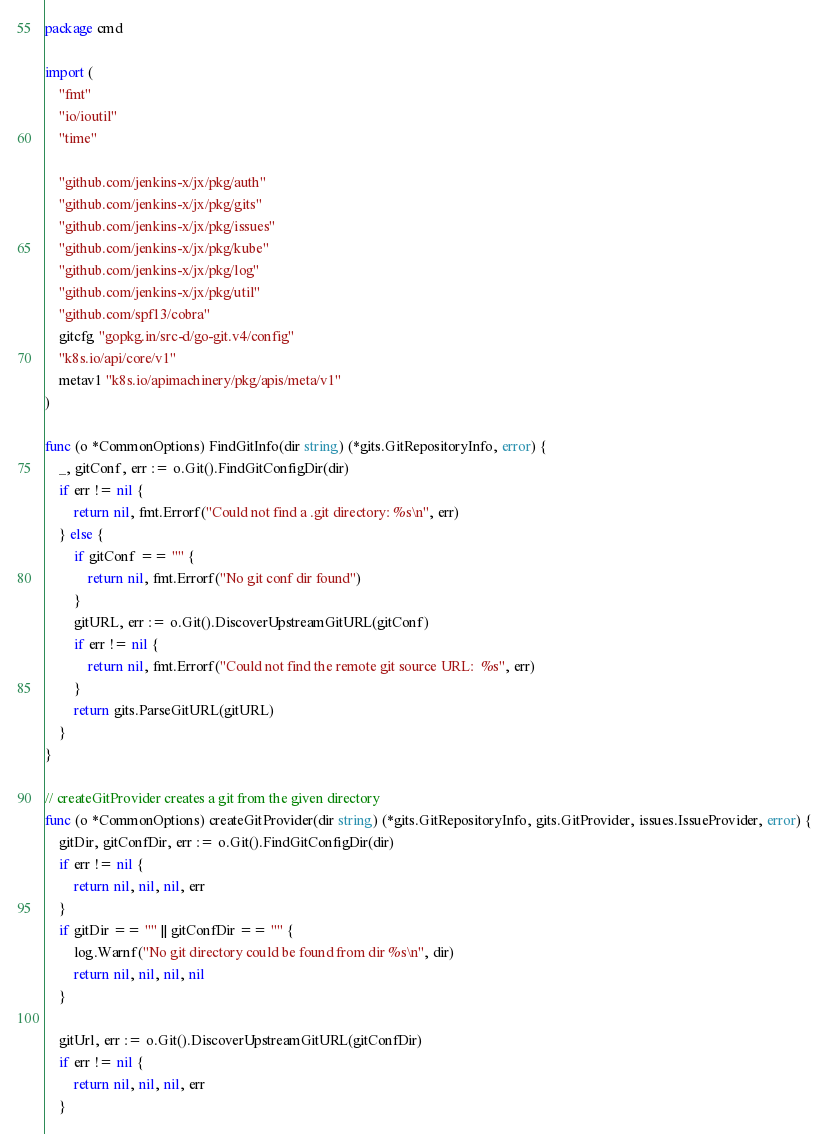<code> <loc_0><loc_0><loc_500><loc_500><_Go_>package cmd

import (
	"fmt"
	"io/ioutil"
	"time"

	"github.com/jenkins-x/jx/pkg/auth"
	"github.com/jenkins-x/jx/pkg/gits"
	"github.com/jenkins-x/jx/pkg/issues"
	"github.com/jenkins-x/jx/pkg/kube"
	"github.com/jenkins-x/jx/pkg/log"
	"github.com/jenkins-x/jx/pkg/util"
	"github.com/spf13/cobra"
	gitcfg "gopkg.in/src-d/go-git.v4/config"
	"k8s.io/api/core/v1"
	metav1 "k8s.io/apimachinery/pkg/apis/meta/v1"
)

func (o *CommonOptions) FindGitInfo(dir string) (*gits.GitRepositoryInfo, error) {
	_, gitConf, err := o.Git().FindGitConfigDir(dir)
	if err != nil {
		return nil, fmt.Errorf("Could not find a .git directory: %s\n", err)
	} else {
		if gitConf == "" {
			return nil, fmt.Errorf("No git conf dir found")
		}
		gitURL, err := o.Git().DiscoverUpstreamGitURL(gitConf)
		if err != nil {
			return nil, fmt.Errorf("Could not find the remote git source URL:  %s", err)
		}
		return gits.ParseGitURL(gitURL)
	}
}

// createGitProvider creates a git from the given directory
func (o *CommonOptions) createGitProvider(dir string) (*gits.GitRepositoryInfo, gits.GitProvider, issues.IssueProvider, error) {
	gitDir, gitConfDir, err := o.Git().FindGitConfigDir(dir)
	if err != nil {
		return nil, nil, nil, err
	}
	if gitDir == "" || gitConfDir == "" {
		log.Warnf("No git directory could be found from dir %s\n", dir)
		return nil, nil, nil, nil
	}

	gitUrl, err := o.Git().DiscoverUpstreamGitURL(gitConfDir)
	if err != nil {
		return nil, nil, nil, err
	}</code> 